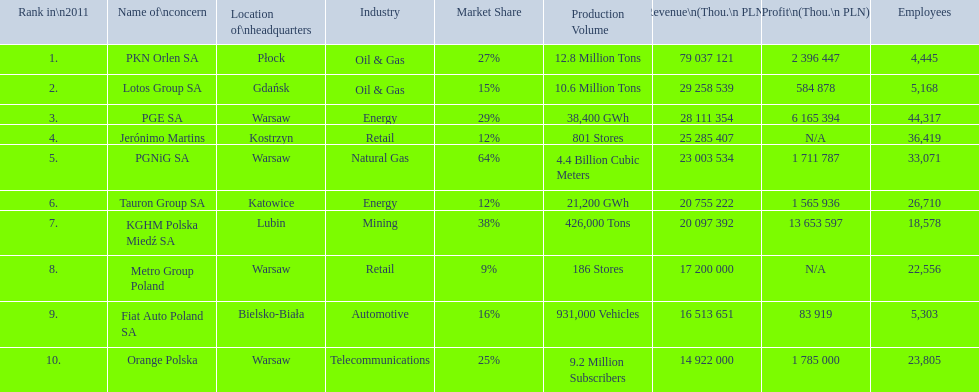What are the names of all the concerns? PKN Orlen SA, Lotos Group SA, PGE SA, Jerónimo Martins, PGNiG SA, Tauron Group SA, KGHM Polska Miedź SA, Metro Group Poland, Fiat Auto Poland SA, Orange Polska. How many employees does pgnig sa have? 33,071. 